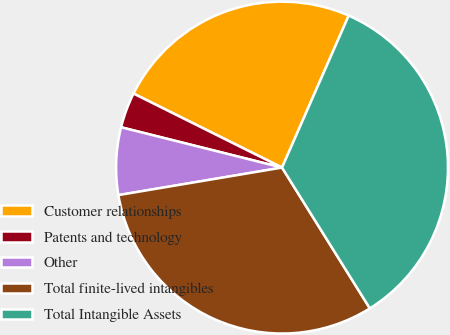<chart> <loc_0><loc_0><loc_500><loc_500><pie_chart><fcel>Customer relationships<fcel>Patents and technology<fcel>Other<fcel>Total finite-lived intangibles<fcel>Total Intangible Assets<nl><fcel>24.22%<fcel>3.45%<fcel>6.56%<fcel>31.22%<fcel>34.54%<nl></chart> 